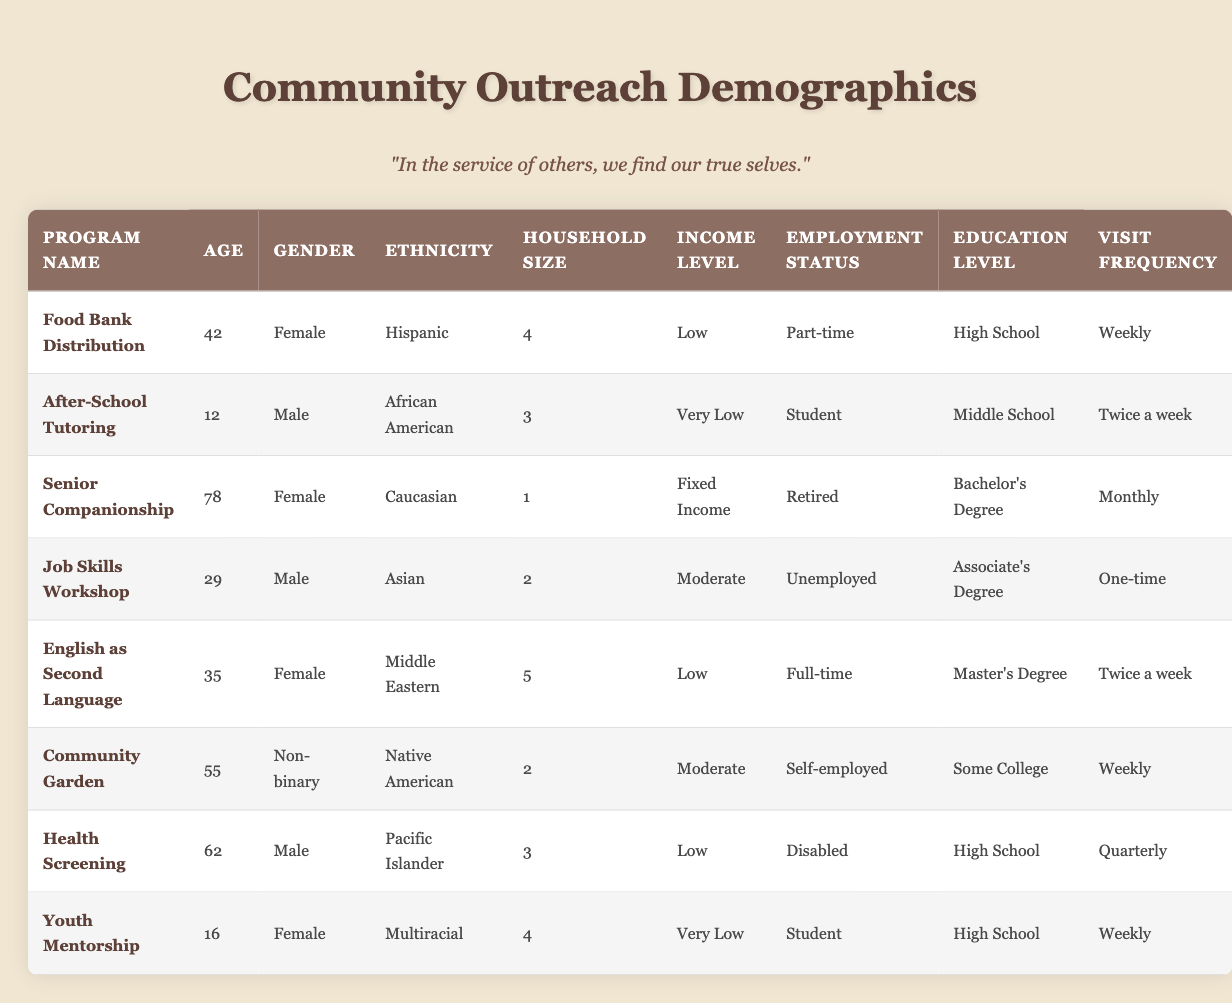What is the average age of participants in the Food Bank Distribution program? The only participant in the Food Bank Distribution program is 42 years old. Since there is just one data point, the average age is simply that age.
Answer: 42 How many participants in the Youth Mentorship program are Female? Looking at the Youth Mentorship program, the participant is 16 years old and identified as Female. Since there is only one participant in this program, that means the count of Female participants is 1.
Answer: 1 What is the most common income level among the participants? The income levels listed for participants in the table are Low, Very Low, Fixed Income, Moderate, and Very Low again (2 occurrences). The income level 'Very Low' appears most frequently at 2 counts.
Answer: Very Low Are there any programs where the participants have a Bachelor's Degree? The only program where participants have a Bachelor's Degree listed is Senior Companionship, as it is specified in the education level column for that program's participant.
Answer: Yes What is the average household size of participants in the Job Skills Workshop and Community Garden programs? The household sizes for participants in these two programs are 2 (Job Skills Workshop) and 2 (Community Garden). To find the average, add these sizes (2 + 2 = 4) and divide by the number of participants (2), which gives an average of 2.
Answer: 2 How many participants are employed full-time? From the table, we can see that only one participant in the English as Second Language program has a full-time employment status. This means the count is 1.
Answer: 1 What percentage of participants in the outreach programs are Male? There are 4 male participants (Health Screening, Job Skills Workshop, and one each in Youth Mentorship and Food Bank Distribution). The total number of participants is 8. To find the percentage, we use the formula (count of males/total participants) × 100, resulting in (4/8) × 100 = 50%.
Answer: 50% How many different ethnicities are represented across the outreach programs? The ethnicities listed in the table are Hispanic, African American, Caucasian, Asian, Middle Eastern, Native American, Pacific Islander, and Multiracial. This counts to a total of 8 different ethnicities represented across all participants.
Answer: 8 